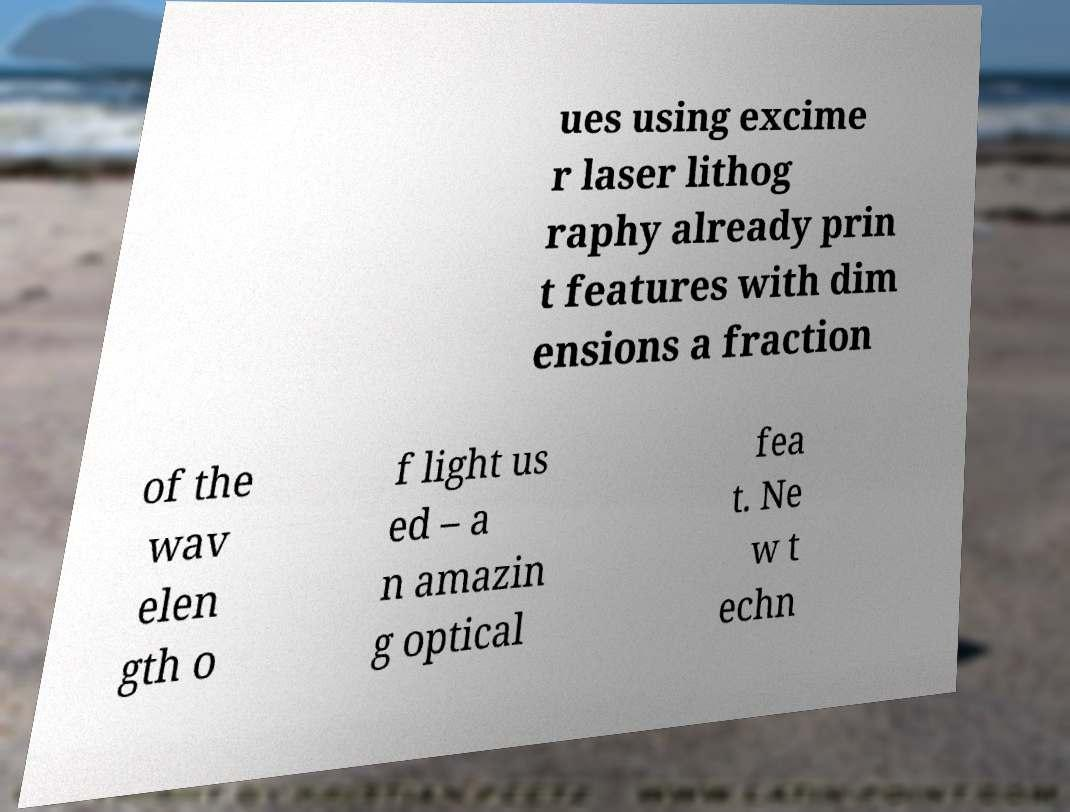For documentation purposes, I need the text within this image transcribed. Could you provide that? ues using excime r laser lithog raphy already prin t features with dim ensions a fraction of the wav elen gth o f light us ed – a n amazin g optical fea t. Ne w t echn 